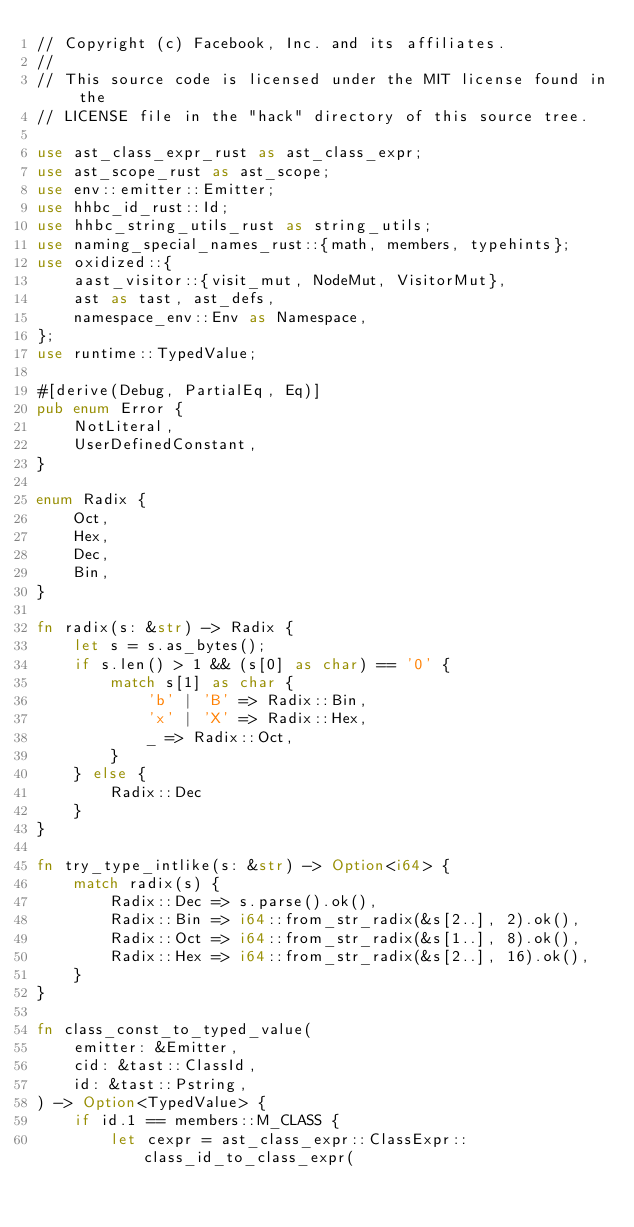<code> <loc_0><loc_0><loc_500><loc_500><_Rust_>// Copyright (c) Facebook, Inc. and its affiliates.
//
// This source code is licensed under the MIT license found in the
// LICENSE file in the "hack" directory of this source tree.

use ast_class_expr_rust as ast_class_expr;
use ast_scope_rust as ast_scope;
use env::emitter::Emitter;
use hhbc_id_rust::Id;
use hhbc_string_utils_rust as string_utils;
use naming_special_names_rust::{math, members, typehints};
use oxidized::{
    aast_visitor::{visit_mut, NodeMut, VisitorMut},
    ast as tast, ast_defs,
    namespace_env::Env as Namespace,
};
use runtime::TypedValue;

#[derive(Debug, PartialEq, Eq)]
pub enum Error {
    NotLiteral,
    UserDefinedConstant,
}

enum Radix {
    Oct,
    Hex,
    Dec,
    Bin,
}

fn radix(s: &str) -> Radix {
    let s = s.as_bytes();
    if s.len() > 1 && (s[0] as char) == '0' {
        match s[1] as char {
            'b' | 'B' => Radix::Bin,
            'x' | 'X' => Radix::Hex,
            _ => Radix::Oct,
        }
    } else {
        Radix::Dec
    }
}

fn try_type_intlike(s: &str) -> Option<i64> {
    match radix(s) {
        Radix::Dec => s.parse().ok(),
        Radix::Bin => i64::from_str_radix(&s[2..], 2).ok(),
        Radix::Oct => i64::from_str_radix(&s[1..], 8).ok(),
        Radix::Hex => i64::from_str_radix(&s[2..], 16).ok(),
    }
}

fn class_const_to_typed_value(
    emitter: &Emitter,
    cid: &tast::ClassId,
    id: &tast::Pstring,
) -> Option<TypedValue> {
    if id.1 == members::M_CLASS {
        let cexpr = ast_class_expr::ClassExpr::class_id_to_class_expr(</code> 